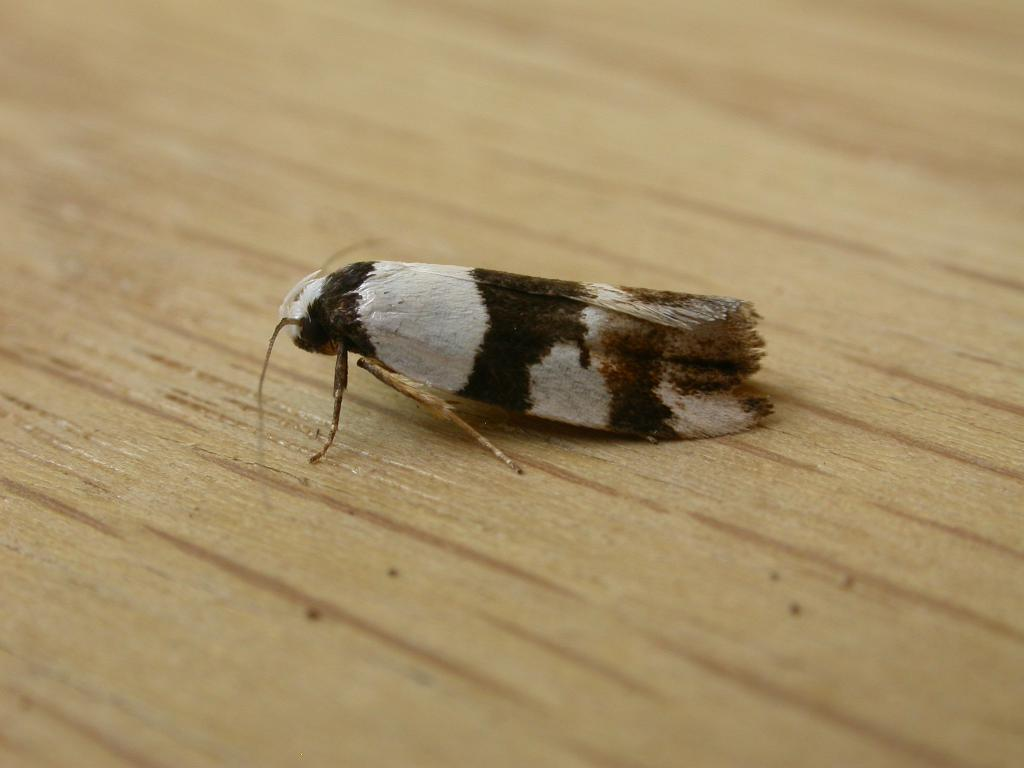What type of insect is in the image? There is a moth in the image. What colors are present on the moth? The moth is black and white. What is the moth resting on in the image? The moth is on a brown surface. What type of root can be seen growing from the moth in the image? There is no root growing from the moth in the image; it is a moth, not a plant. 